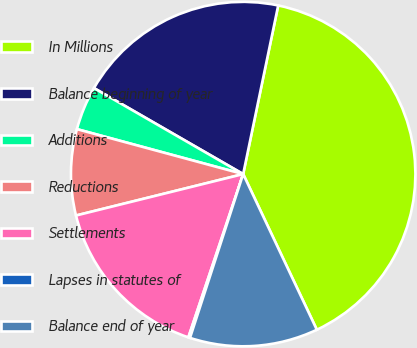Convert chart to OTSL. <chart><loc_0><loc_0><loc_500><loc_500><pie_chart><fcel>In Millions<fcel>Balance beginning of year<fcel>Additions<fcel>Reductions<fcel>Settlements<fcel>Lapses in statutes of<fcel>Balance end of year<nl><fcel>39.71%<fcel>19.94%<fcel>4.12%<fcel>8.07%<fcel>15.98%<fcel>0.16%<fcel>12.03%<nl></chart> 